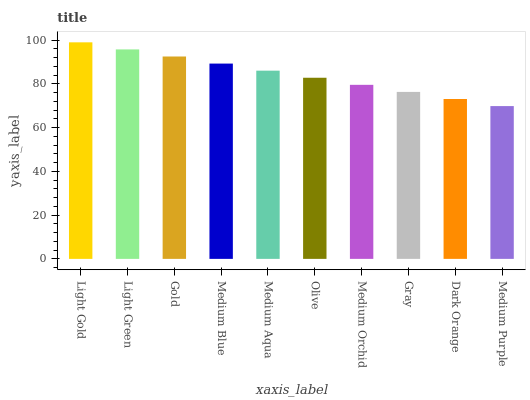Is Medium Purple the minimum?
Answer yes or no. Yes. Is Light Gold the maximum?
Answer yes or no. Yes. Is Light Green the minimum?
Answer yes or no. No. Is Light Green the maximum?
Answer yes or no. No. Is Light Gold greater than Light Green?
Answer yes or no. Yes. Is Light Green less than Light Gold?
Answer yes or no. Yes. Is Light Green greater than Light Gold?
Answer yes or no. No. Is Light Gold less than Light Green?
Answer yes or no. No. Is Medium Aqua the high median?
Answer yes or no. Yes. Is Olive the low median?
Answer yes or no. Yes. Is Gold the high median?
Answer yes or no. No. Is Medium Orchid the low median?
Answer yes or no. No. 